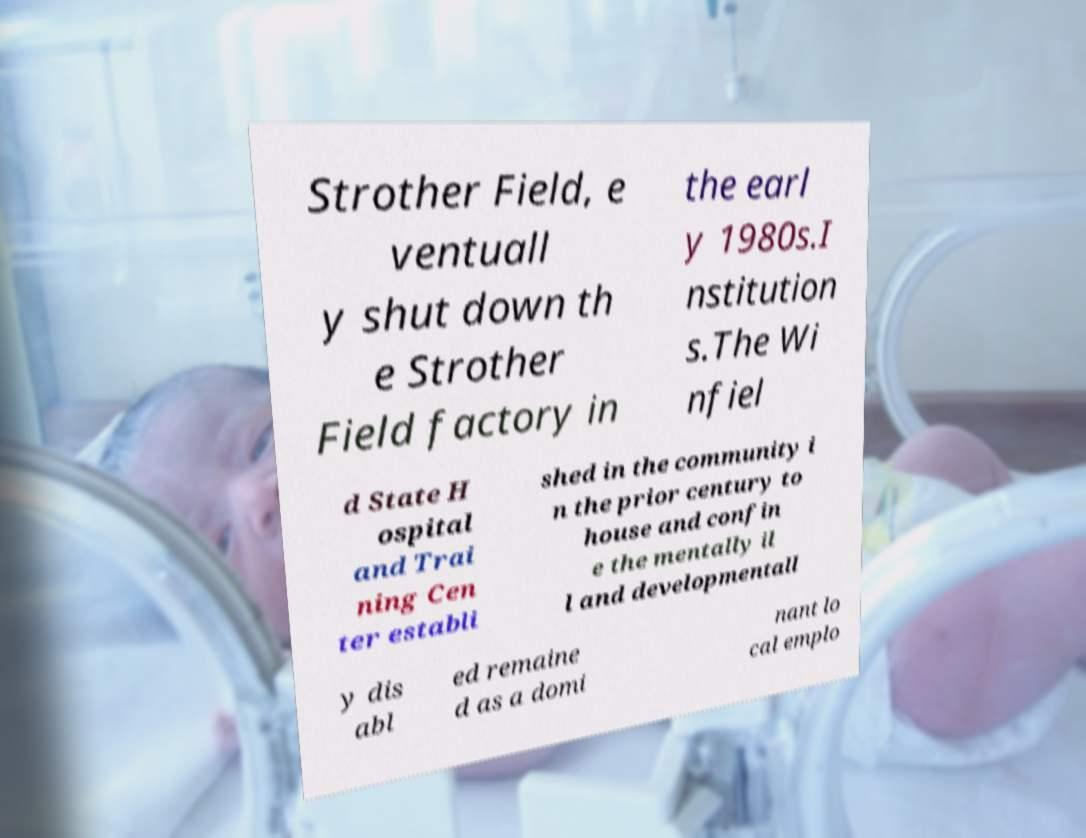Could you assist in decoding the text presented in this image and type it out clearly? Strother Field, e ventuall y shut down th e Strother Field factory in the earl y 1980s.I nstitution s.The Wi nfiel d State H ospital and Trai ning Cen ter establi shed in the community i n the prior century to house and confin e the mentally il l and developmentall y dis abl ed remaine d as a domi nant lo cal emplo 